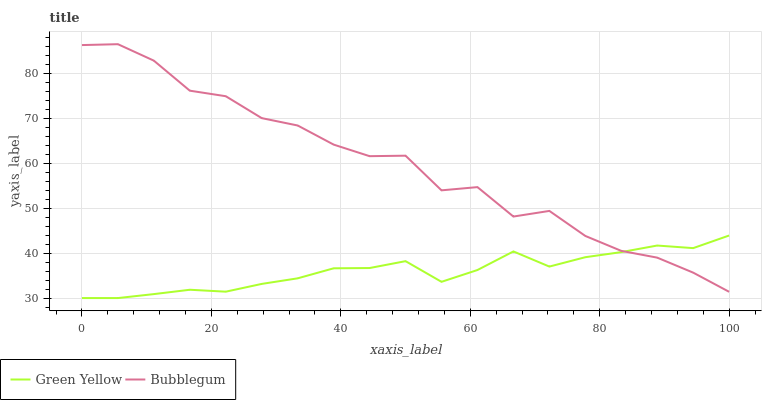Does Bubblegum have the minimum area under the curve?
Answer yes or no. No. Is Bubblegum the smoothest?
Answer yes or no. No. Does Bubblegum have the lowest value?
Answer yes or no. No. 